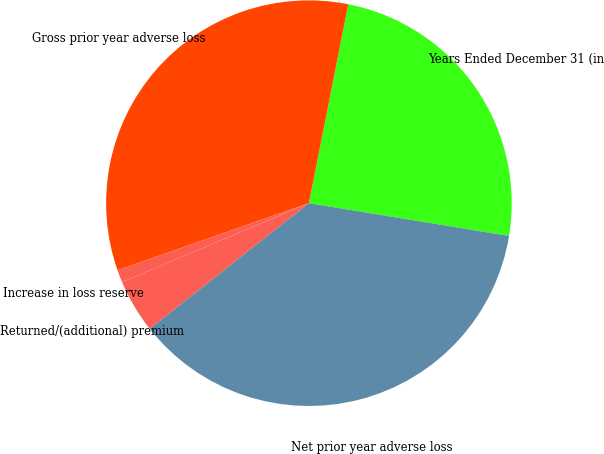Convert chart. <chart><loc_0><loc_0><loc_500><loc_500><pie_chart><fcel>Years Ended December 31 (in<fcel>Gross prior year adverse loss<fcel>Increase in loss reserve<fcel>Returned/(additional) premium<fcel>Net prior year adverse loss<nl><fcel>24.47%<fcel>33.48%<fcel>0.99%<fcel>4.28%<fcel>36.78%<nl></chart> 